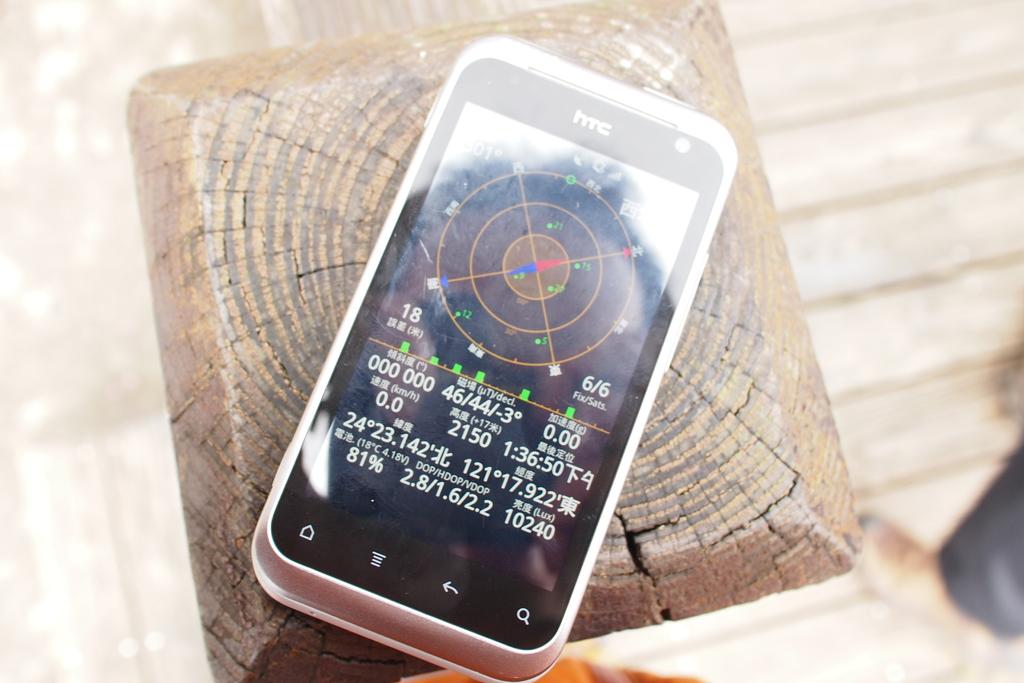What brand is this phone?
Provide a succinct answer. Htc. What are the numbers on the bottom right?
Keep it short and to the point. 10240. 